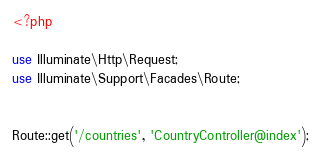Convert code to text. <code><loc_0><loc_0><loc_500><loc_500><_PHP_><?php

use Illuminate\Http\Request;
use Illuminate\Support\Facades\Route;


Route::get('/countries', 'CountryController@index');

</code> 